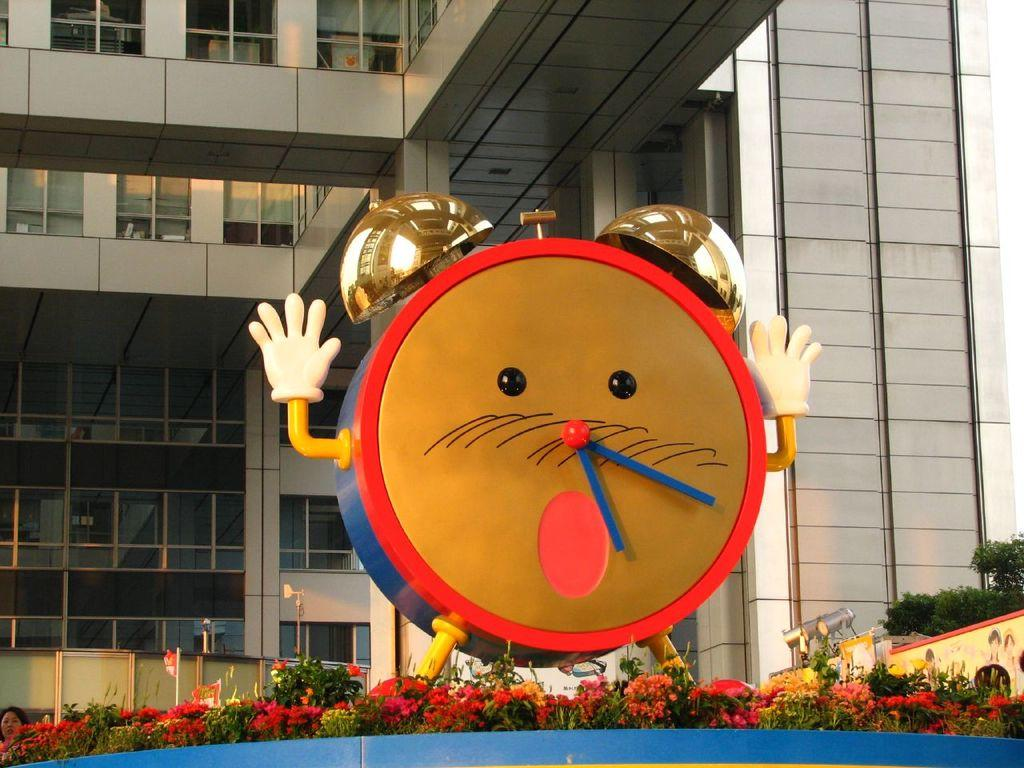What is the main object in the center of the image? There is an alarm clock in the center of the image. What can be seen in the background of the image? There is a building in the background of the image. What type of vegetation is on the right side of the image? There are trees on the right side of the image. What is located at the bottom of the image? There are flowers at the bottom of the image. What type of baseball trousers can be seen in the image? There is no baseball or trousers present in the image. Can you see any steam coming from the alarm clock in the image? There is no steam present in the image, as it features an alarm clock, a building, trees, and flowers. 